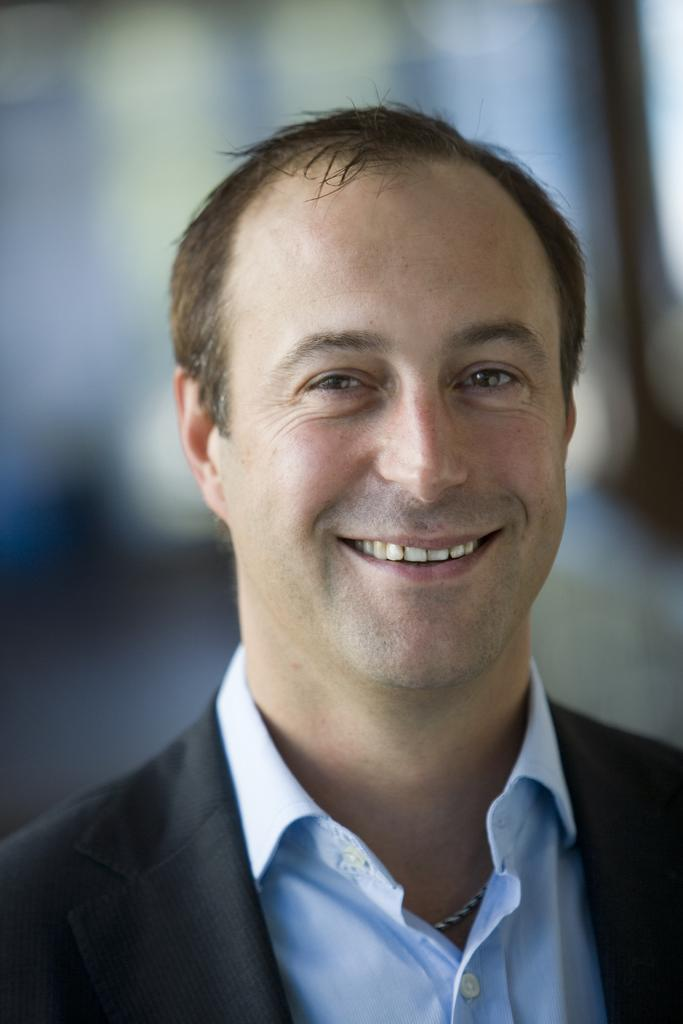Who is present in the image? There is a man in the image. What is the man wearing? The man is wearing a black jacket. Can you describe the background of the image? The background of the image is blurred. What type of property is the man inspecting in the image? There is no property visible in the image, and the man is not inspecting anything. 